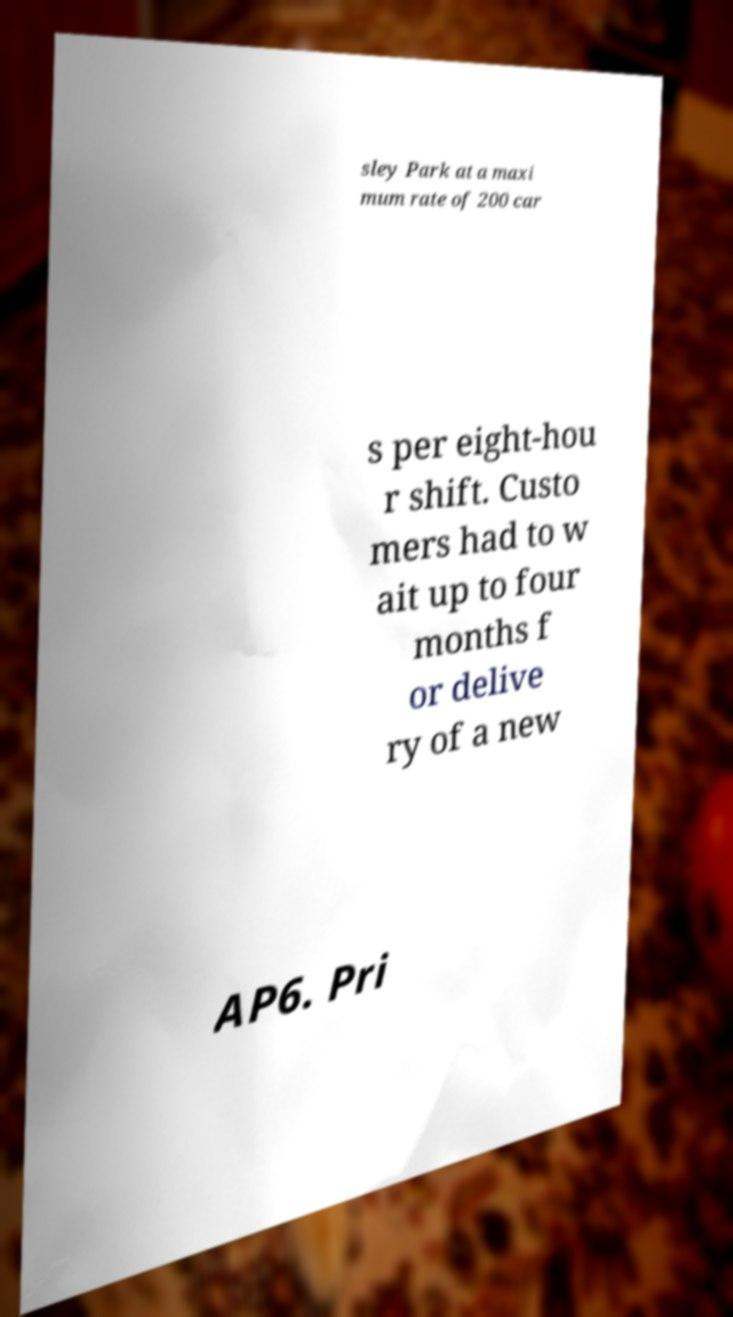I need the written content from this picture converted into text. Can you do that? sley Park at a maxi mum rate of 200 car s per eight-hou r shift. Custo mers had to w ait up to four months f or delive ry of a new AP6. Pri 